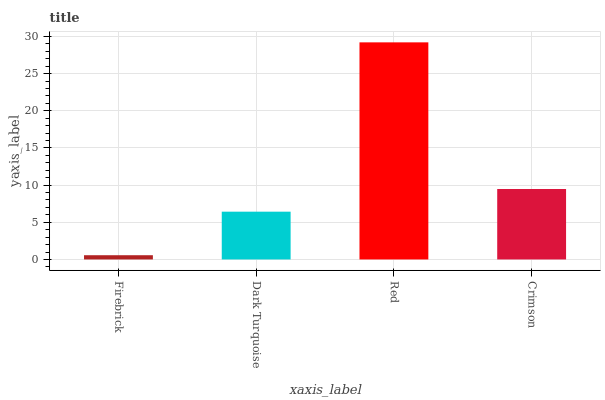Is Dark Turquoise the minimum?
Answer yes or no. No. Is Dark Turquoise the maximum?
Answer yes or no. No. Is Dark Turquoise greater than Firebrick?
Answer yes or no. Yes. Is Firebrick less than Dark Turquoise?
Answer yes or no. Yes. Is Firebrick greater than Dark Turquoise?
Answer yes or no. No. Is Dark Turquoise less than Firebrick?
Answer yes or no. No. Is Crimson the high median?
Answer yes or no. Yes. Is Dark Turquoise the low median?
Answer yes or no. Yes. Is Dark Turquoise the high median?
Answer yes or no. No. Is Crimson the low median?
Answer yes or no. No. 